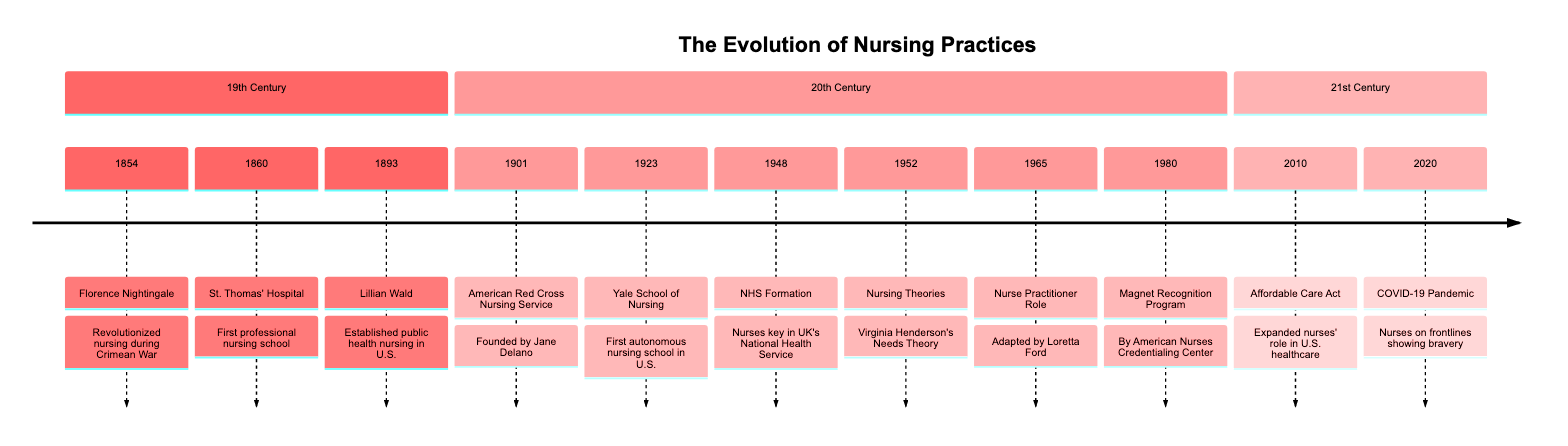What year did Florence Nightingale revolutionize nursing? The timeline indicates that Florence Nightingale revolutionized nursing during the Crimean War in the year 1854.
Answer: 1854 Who established public health nursing in the U.S.? According to the timeline, Lillian Wald is the individual credited with establishing public health nursing in the U.S. in the year 1893.
Answer: Lillian Wald Which organization was founded by Jane Delano? The timeline shows that the American Red Cross Nursing Service was founded by Jane Delano in the year 1901.
Answer: American Red Cross Nursing Service What significant nursing educational institution was established in 1923? The timeline lists the Yale School of Nursing as the first autonomous nursing school in the U.S., established in 1923.
Answer: Yale School of Nursing In what year did the NHS Formation occur? The timeline reflects that the formation of the NHS occurred in the year 1948, highlighting the role of nurses in the UK's National Health Service.
Answer: 1948 How did the Affordable Care Act affect nurses' roles? The timeline states that the Affordable Care Act, enacted in 2010, expanded nurses' roles in U.S. healthcare, indicating a significant shift in their responsibilities.
Answer: Expanded nurses' role What role was adapted by Loretta Ford in 1965? Based on the timeline, Loretta Ford adapted the Nurse Practitioner role in 1965, marking an important development in nursing practices.
Answer: Nurse Practitioner Role How many significant events are listed in the 20th Century section of the timeline? Counting the events listed in the 20th Century section indicates there are six significant milestones: from 1901 to 1980.
Answer: 6 What major global health crisis did nurses face in 2020? The timeline details that nurses were prominent on the frontlines during the COVID-19 Pandemic, indicating the major global health crisis faced in that year.
Answer: COVID-19 Pandemic 